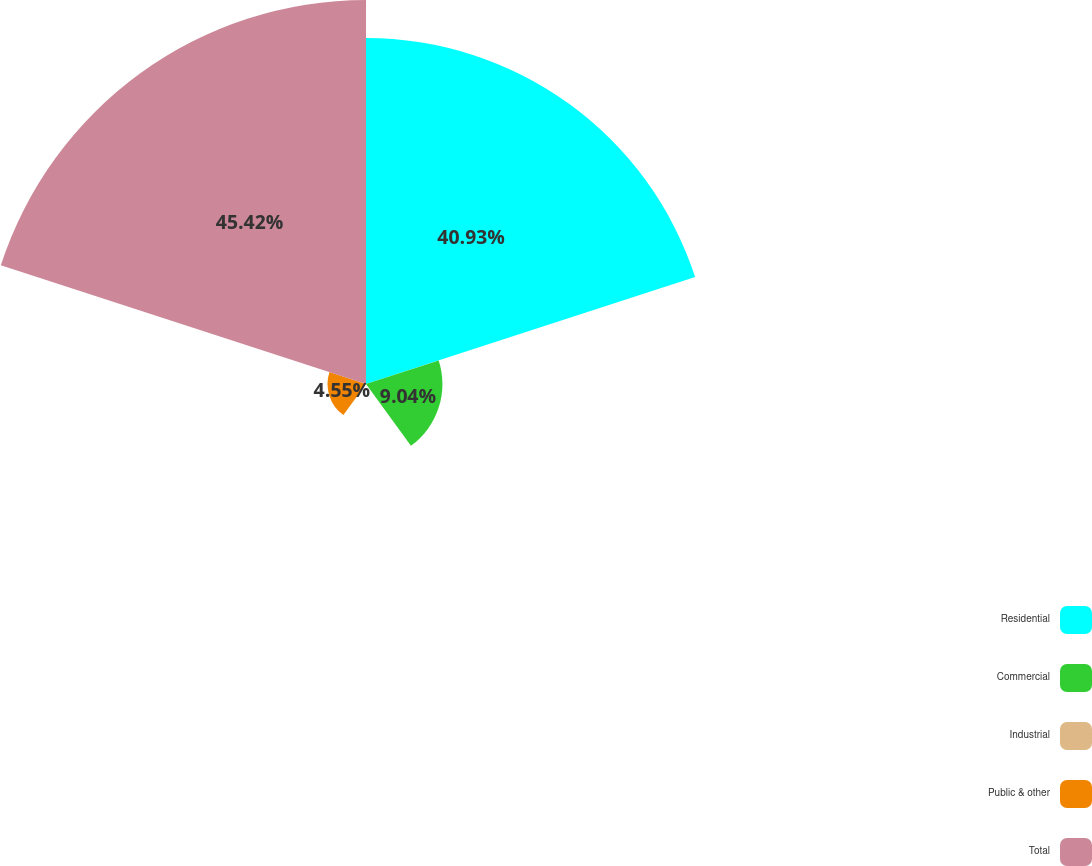Convert chart. <chart><loc_0><loc_0><loc_500><loc_500><pie_chart><fcel>Residential<fcel>Commercial<fcel>Industrial<fcel>Public & other<fcel>Total<nl><fcel>40.93%<fcel>9.04%<fcel>0.06%<fcel>4.55%<fcel>45.42%<nl></chart> 